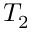Convert formula to latex. <formula><loc_0><loc_0><loc_500><loc_500>T _ { 2 }</formula> 